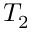Convert formula to latex. <formula><loc_0><loc_0><loc_500><loc_500>T _ { 2 }</formula> 